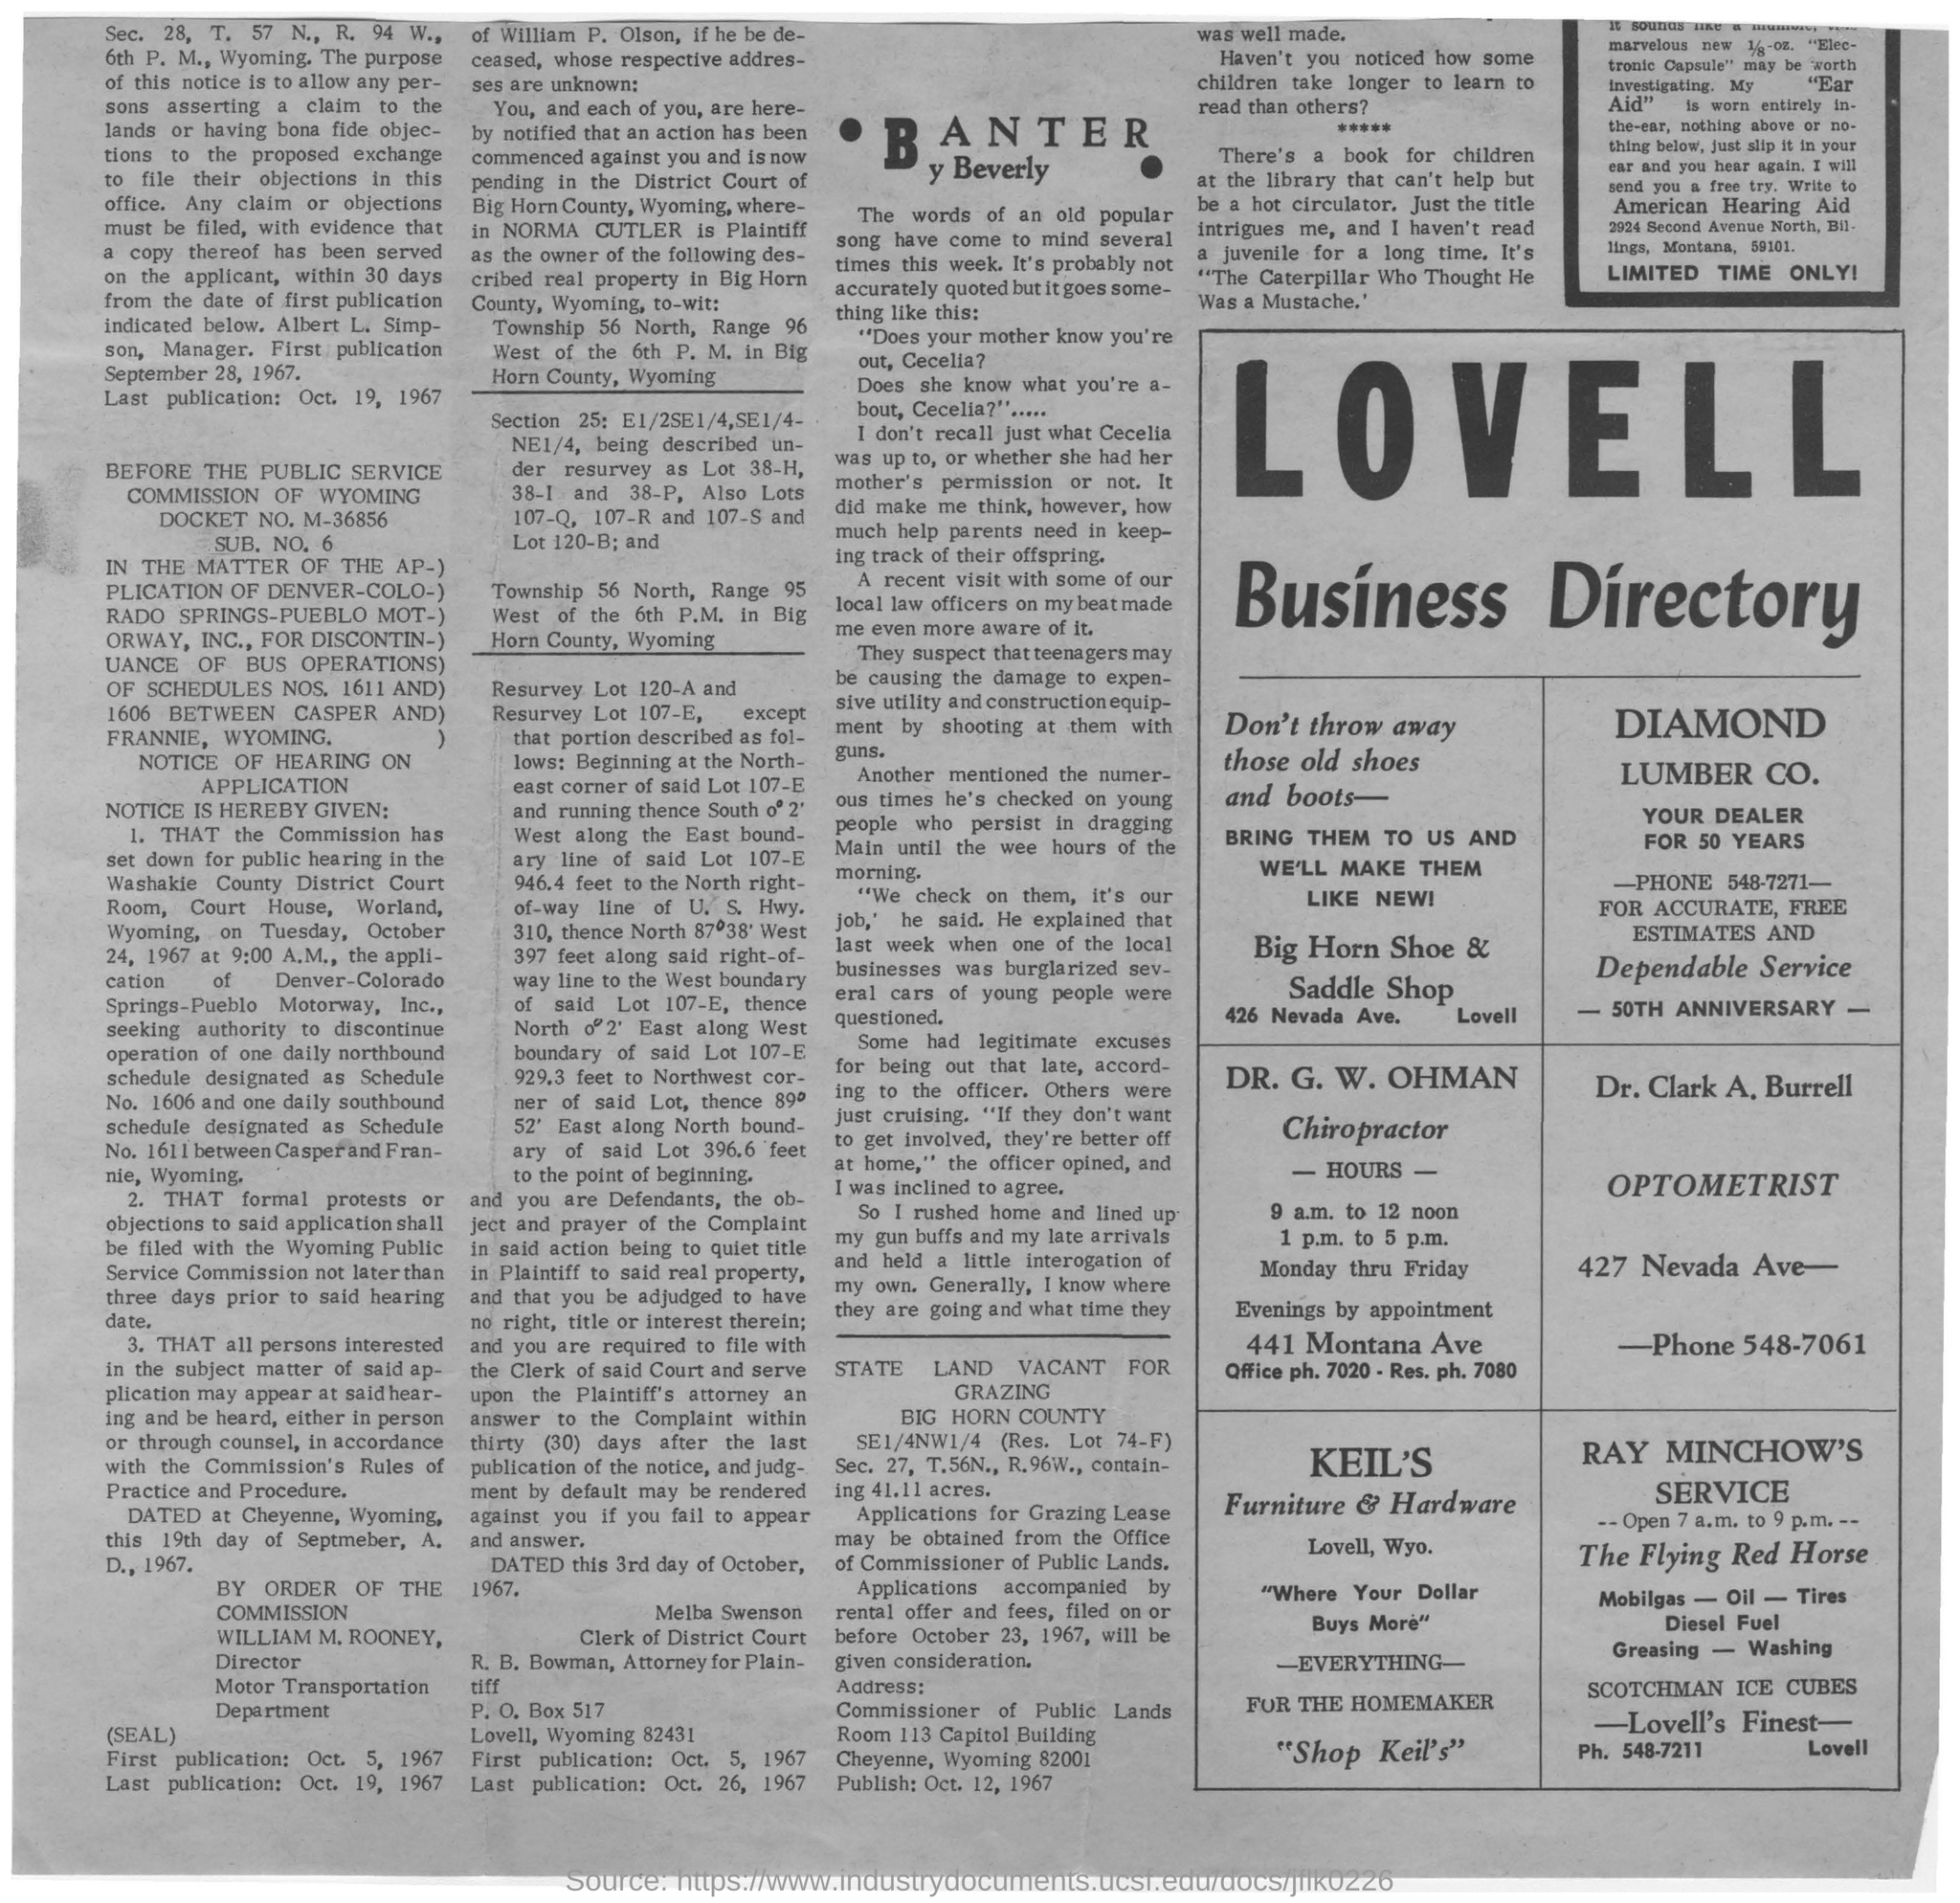Point out several critical features in this image. Ray Minchow's Service is open from 7:00 a.m. to 9:00 p.m. I am aware of a company called Keil's Furniture & Hardware. The Business Directory's name is Lovell. The optometrist is Dr. Clark A. Burrell. 